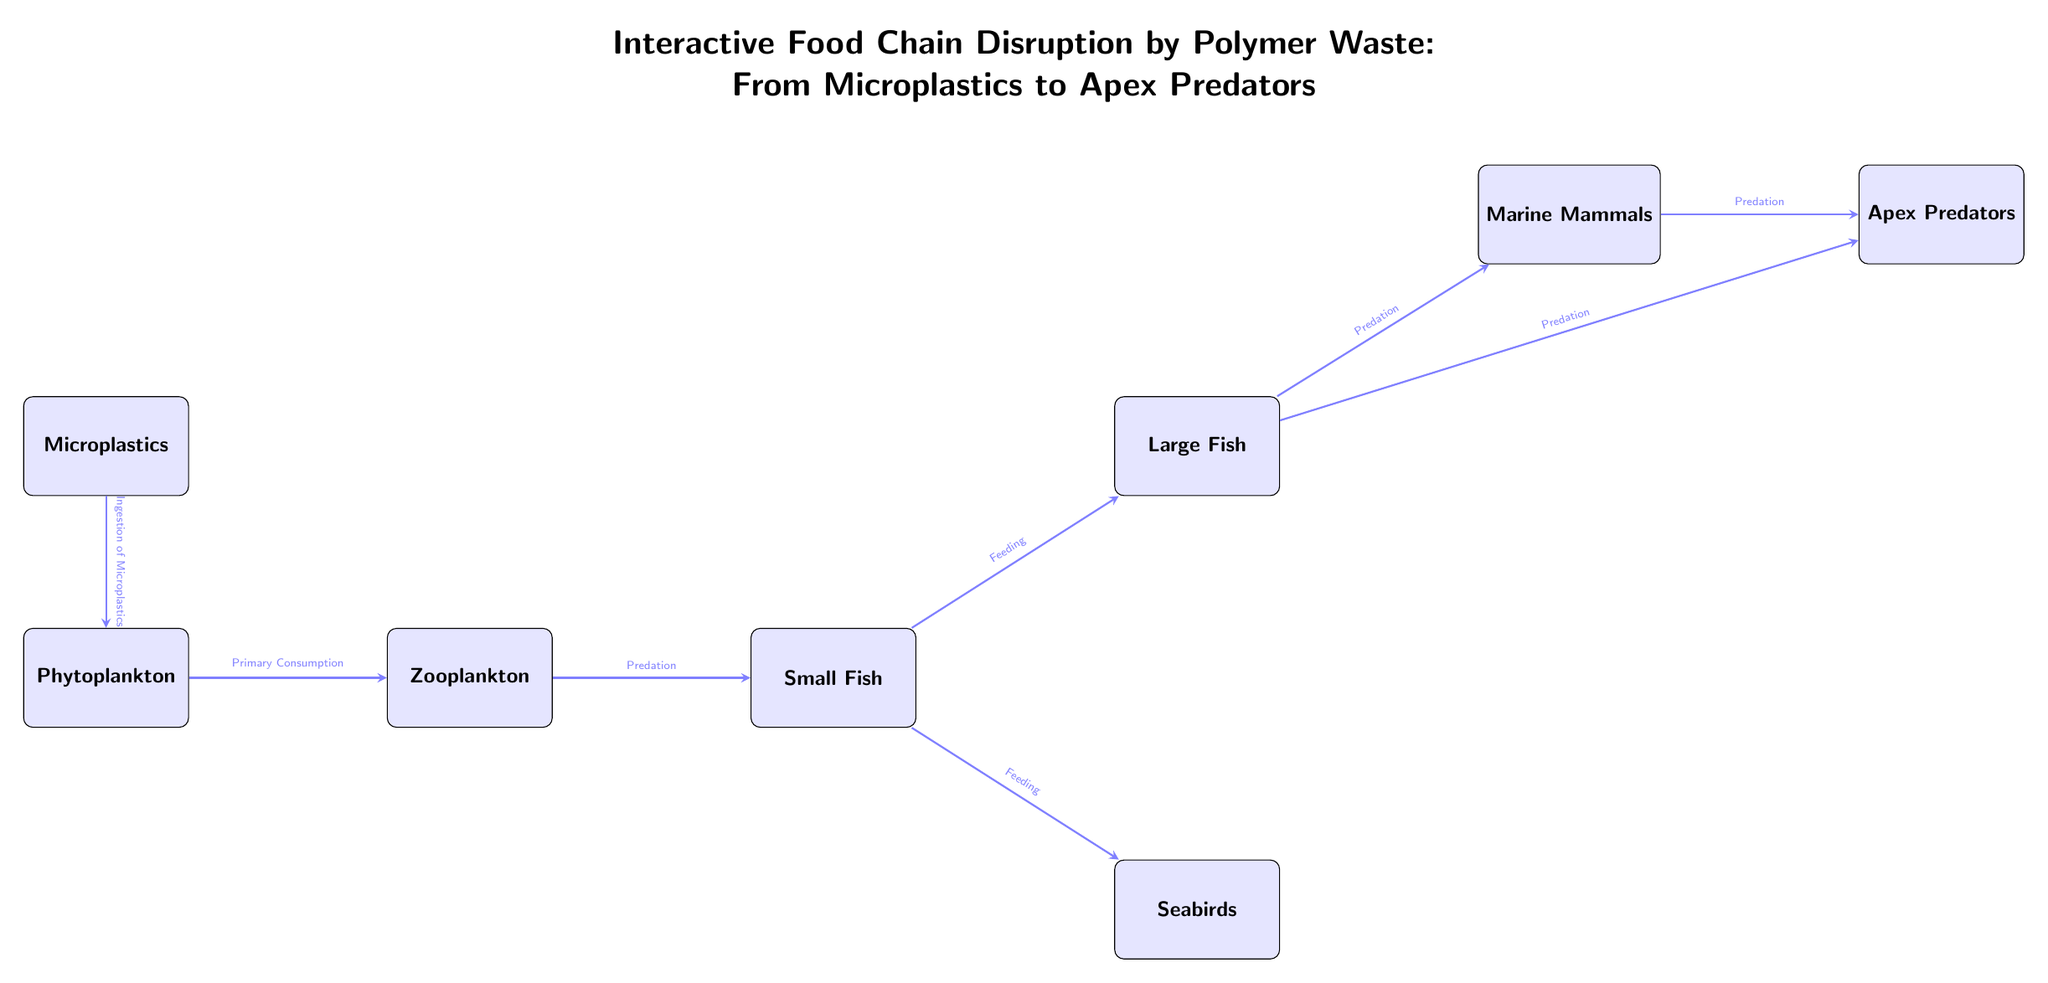What is the first node in the food chain? The first node in the food chain is represented by the node for Microplastics, which is positioned at the top of the diagram.
Answer: Microplastics How many total nodes are present in the diagram? The diagram visually represents a total of eight nodes, including Microplastics, Phytoplankton, Zooplankton, Small Fish, Large Fish, Seabirds, Marine Mammals, and Apex Predators.
Answer: 8 What type of consumption occurs between Phytoplankton and Zooplankton? The relationship between Phytoplankton and Zooplankton in the diagram is labeled as Primary Consumption, indicating that Zooplankton consume Phytoplankton.
Answer: Primary Consumption Which node is directly impacted by Small Fish in the food chain? Small Fish have two direct relationships in the diagram, feeding into both the Large Fish and the Seabirds nodes, thus impacting both of them directly.
Answer: Large Fish and Seabirds What type of predation connects Large Fish and Marine Mammals? The diagram indicates that the relationship between Large Fish and Marine Mammals is labeled as Predation, meaning that Marine Mammals prey on Large Fish.
Answer: Predation Based on the flow of the diagram, which node would be affected last by the Microplastics? The flow of the diagram shows that Apex Predators would be the last group affected by Microplastics since they are at the end of the food chain, and all other nodes must be impacted first.
Answer: Apex Predators How many arrows are leading out of the Small Fish node? The Small Fish node has two arrows leading out of it, one towards Large Fish and one towards Seabirds, indicating two separate feeding relationships.
Answer: 2 What role does Zooplankton play in relation to Phytoplankton? In the food chain, Zooplankton acts as the primary consumer of Phytoplankton, meaning they feed on them directly, thus establishing a critical relationship in the ecosystem.
Answer: Primary Consumer 